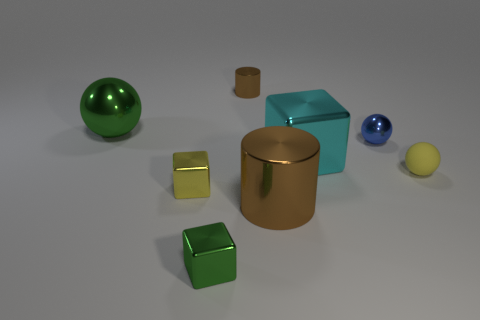There is a tiny metal block that is on the left side of the green shiny block; does it have the same color as the small rubber thing?
Keep it short and to the point. Yes. There is another thing that is the same color as the rubber object; what is its shape?
Offer a terse response. Cube. There is a metallic thing that is the same color as the big cylinder; what size is it?
Your answer should be compact. Small. Are there more cyan shiny things than spheres?
Your answer should be very brief. No. The big thing that is to the left of the tiny yellow cube is what color?
Keep it short and to the point. Green. Is the number of green metallic things on the left side of the small brown shiny cylinder greater than the number of big cyan shiny cubes?
Provide a succinct answer. Yes. Does the cyan block have the same material as the tiny brown thing?
Offer a very short reply. Yes. How many other things are the same shape as the big cyan shiny object?
Ensure brevity in your answer.  2. Is there any other thing that has the same material as the small yellow ball?
Give a very brief answer. No. What is the color of the tiny thing that is to the left of the green shiny object that is in front of the small yellow thing that is on the right side of the cyan metallic thing?
Offer a terse response. Yellow. 